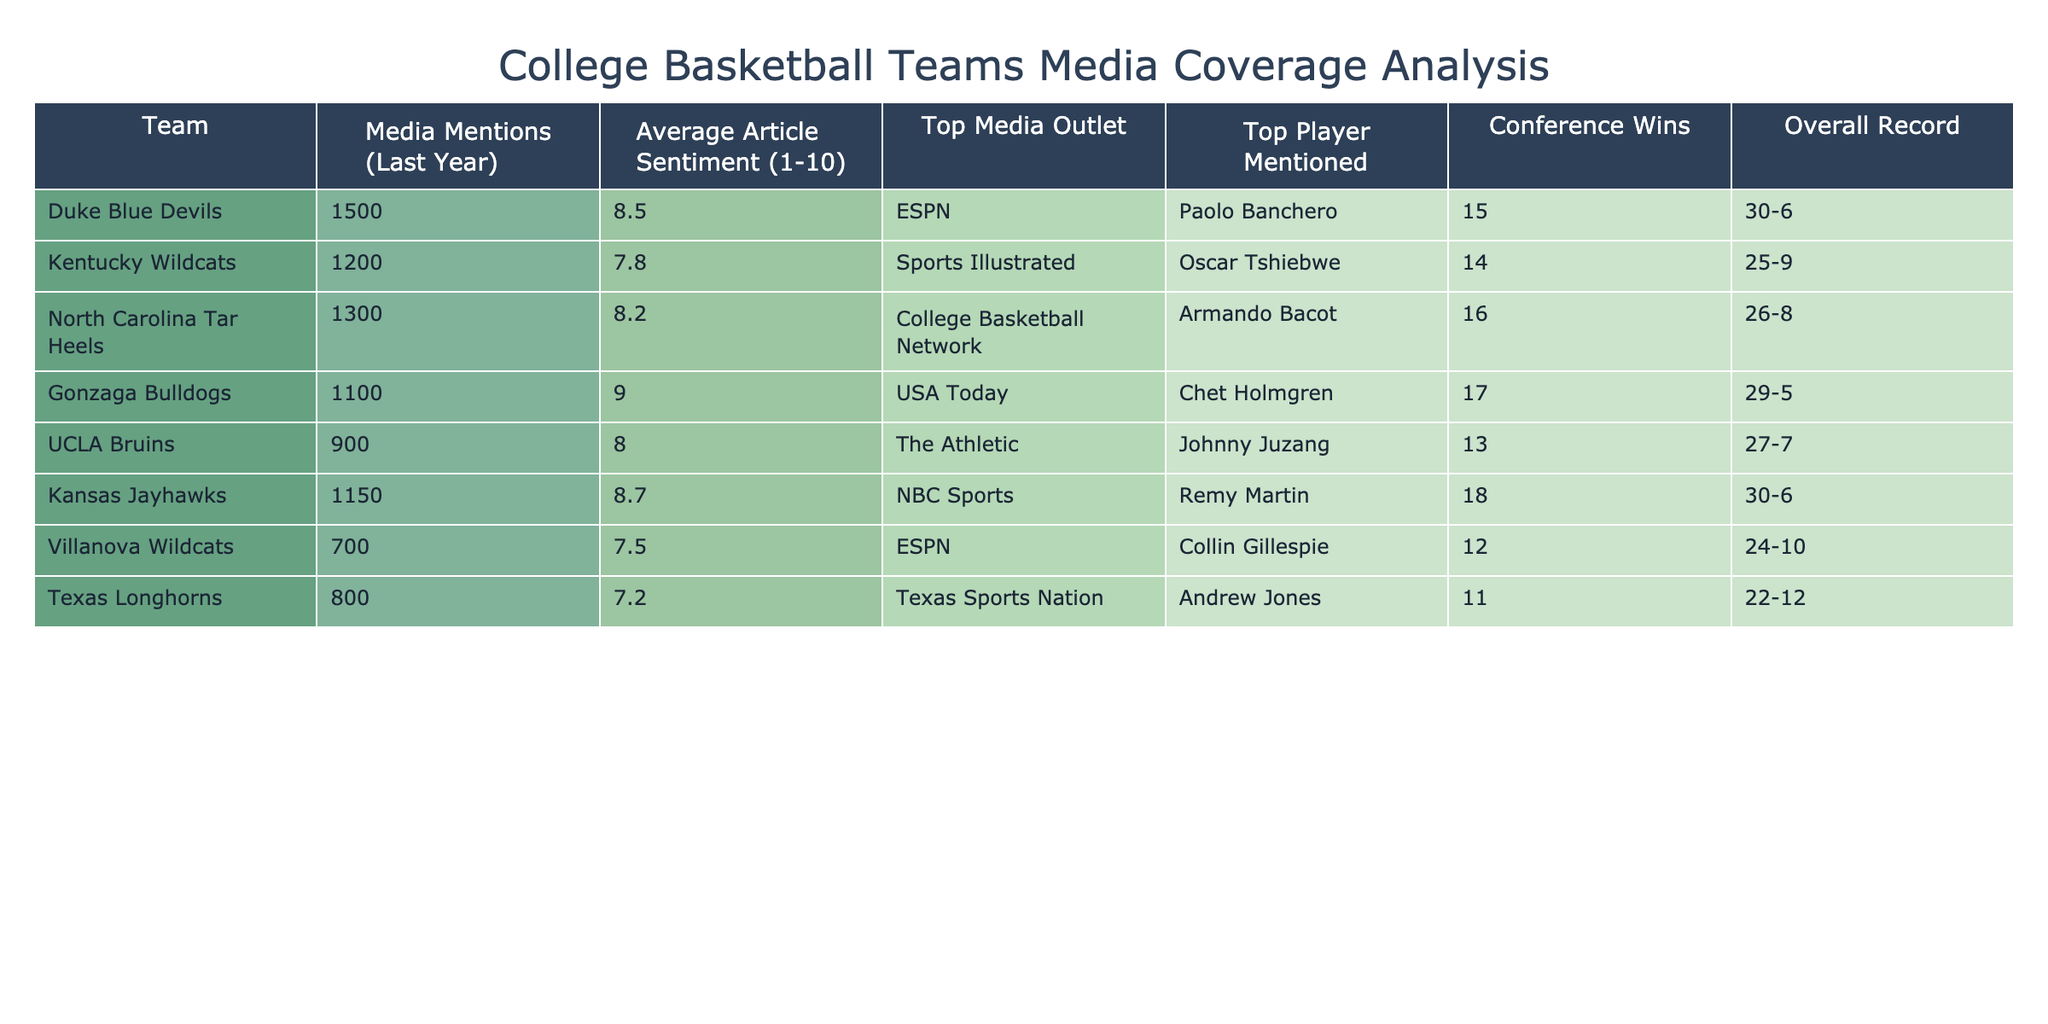What is the team with the highest media mentions? By examining the "Media Mentions (Last Year)" column, the highest value is 1500, which corresponds to the Duke Blue Devils.
Answer: Duke Blue Devils Which team has the highest average article sentiment score? Looking at the "Average Article Sentiment (1-10)" column, the highest score listed is 9.0, attributed to the Gonzaga Bulldogs.
Answer: Gonzaga Bulldogs How many conference wins did the Kentucky Wildcats achieve? The "Conference Wins" column shows that Kentucky Wildcats recorded 14 wins.
Answer: 14 What is the overall record for the team with the lowest media mentions? The team with the lowest media mentions is the Villanova Wildcats with 700 mentions. Their overall record, as found in the "Overall Record" column, is 24-10.
Answer: 24-10 Is there a team with an average article sentiment score of less than 8? The Texas Longhorns have an average article sentiment score of 7.2, which is indeed less than 8.
Answer: Yes What is the total number of conference wins for teams from the top three mentioned in media coverage? The teams with the highest media mentions are Duke (15), North Carolina (16), and Kentucky (14). The total conference wins are 15 + 16 + 14 = 45.
Answer: 45 Which player was most mentioned in media articles for the Kansas Jayhawks? The "Top Player Mentioned" column for Kansas Jayhawks indicates that Remy Martin was the most mentioned player.
Answer: Remy Martin Do the UCLA Bruins have more wins than the Texas Longhorns? The UCLA Bruins recorded 13 wins, while the Texas Longhorns had 11 wins as noted in the "Conference Wins" column. Therefore, UCLA has more wins than Texas.
Answer: Yes What is the average sentiment score of the teams in the table? To find the average, sum up the average sentiment scores (8.5 + 7.8 + 8.2 + 9.0 + 8.0 + 8.7 + 7.5 + 7.2) which equals 67.9, and divide by the number of teams (8) to get 67.9 / 8 = 8.4875, which rounds to approximately 8.5.
Answer: 8.5 